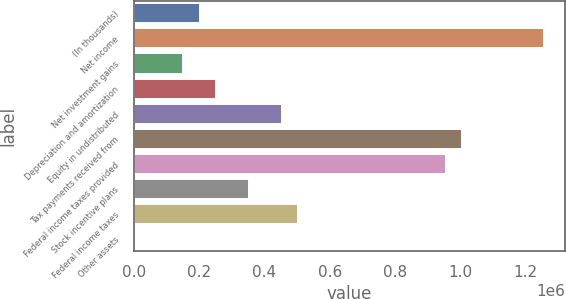<chart> <loc_0><loc_0><loc_500><loc_500><bar_chart><fcel>(In thousands)<fcel>Net income<fcel>Net investment gains<fcel>Depreciation and amortization<fcel>Equity in undistributed<fcel>Tax payments received from<fcel>Federal income taxes provided<fcel>Stock incentive plans<fcel>Federal income taxes<fcel>Other assets<nl><fcel>201658<fcel>1.25878e+06<fcel>151319<fcel>251998<fcel>453355<fcel>1.00709e+06<fcel>956748<fcel>352676<fcel>503694<fcel>301<nl></chart> 